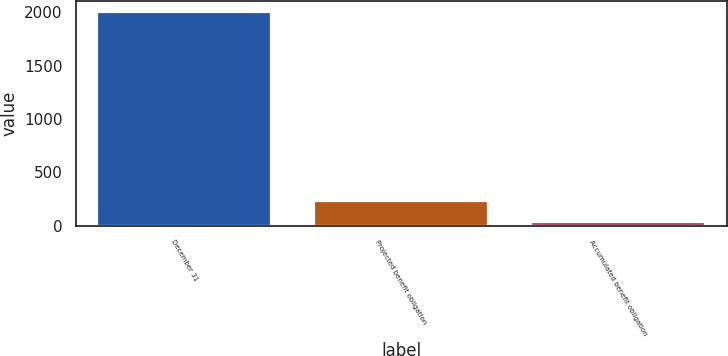<chart> <loc_0><loc_0><loc_500><loc_500><bar_chart><fcel>December 31<fcel>Projected benefit obligation<fcel>Accumulated benefit obligation<nl><fcel>2005<fcel>231.1<fcel>34<nl></chart> 